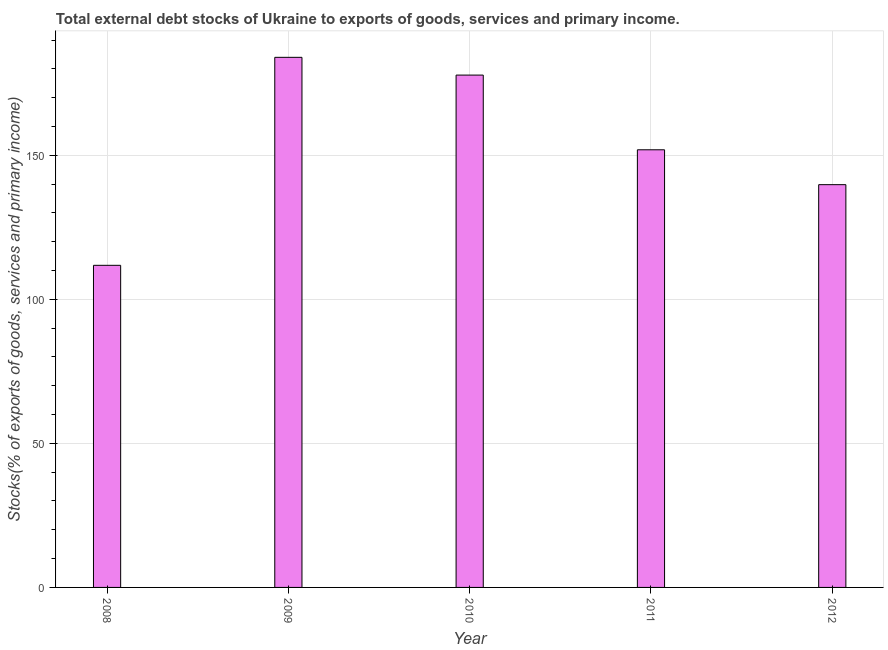Does the graph contain grids?
Offer a terse response. Yes. What is the title of the graph?
Your answer should be compact. Total external debt stocks of Ukraine to exports of goods, services and primary income. What is the label or title of the Y-axis?
Provide a succinct answer. Stocks(% of exports of goods, services and primary income). What is the external debt stocks in 2011?
Give a very brief answer. 151.9. Across all years, what is the maximum external debt stocks?
Give a very brief answer. 183.99. Across all years, what is the minimum external debt stocks?
Provide a short and direct response. 111.79. What is the sum of the external debt stocks?
Make the answer very short. 765.29. What is the difference between the external debt stocks in 2009 and 2012?
Ensure brevity in your answer.  44.19. What is the average external debt stocks per year?
Your answer should be compact. 153.06. What is the median external debt stocks?
Offer a terse response. 151.9. What is the ratio of the external debt stocks in 2008 to that in 2011?
Give a very brief answer. 0.74. Is the external debt stocks in 2010 less than that in 2012?
Provide a short and direct response. No. Is the difference between the external debt stocks in 2010 and 2012 greater than the difference between any two years?
Your response must be concise. No. What is the difference between the highest and the second highest external debt stocks?
Make the answer very short. 6.16. Is the sum of the external debt stocks in 2009 and 2011 greater than the maximum external debt stocks across all years?
Ensure brevity in your answer.  Yes. What is the difference between the highest and the lowest external debt stocks?
Offer a terse response. 72.19. Are all the bars in the graph horizontal?
Provide a succinct answer. No. How many years are there in the graph?
Your answer should be compact. 5. What is the Stocks(% of exports of goods, services and primary income) in 2008?
Offer a terse response. 111.79. What is the Stocks(% of exports of goods, services and primary income) in 2009?
Provide a succinct answer. 183.99. What is the Stocks(% of exports of goods, services and primary income) in 2010?
Your response must be concise. 177.82. What is the Stocks(% of exports of goods, services and primary income) in 2011?
Your response must be concise. 151.9. What is the Stocks(% of exports of goods, services and primary income) of 2012?
Keep it short and to the point. 139.79. What is the difference between the Stocks(% of exports of goods, services and primary income) in 2008 and 2009?
Make the answer very short. -72.19. What is the difference between the Stocks(% of exports of goods, services and primary income) in 2008 and 2010?
Offer a terse response. -66.03. What is the difference between the Stocks(% of exports of goods, services and primary income) in 2008 and 2011?
Provide a short and direct response. -40.1. What is the difference between the Stocks(% of exports of goods, services and primary income) in 2008 and 2012?
Your answer should be compact. -28. What is the difference between the Stocks(% of exports of goods, services and primary income) in 2009 and 2010?
Your answer should be compact. 6.16. What is the difference between the Stocks(% of exports of goods, services and primary income) in 2009 and 2011?
Your answer should be compact. 32.09. What is the difference between the Stocks(% of exports of goods, services and primary income) in 2009 and 2012?
Your response must be concise. 44.19. What is the difference between the Stocks(% of exports of goods, services and primary income) in 2010 and 2011?
Offer a terse response. 25.93. What is the difference between the Stocks(% of exports of goods, services and primary income) in 2010 and 2012?
Make the answer very short. 38.03. What is the difference between the Stocks(% of exports of goods, services and primary income) in 2011 and 2012?
Offer a very short reply. 12.11. What is the ratio of the Stocks(% of exports of goods, services and primary income) in 2008 to that in 2009?
Ensure brevity in your answer.  0.61. What is the ratio of the Stocks(% of exports of goods, services and primary income) in 2008 to that in 2010?
Give a very brief answer. 0.63. What is the ratio of the Stocks(% of exports of goods, services and primary income) in 2008 to that in 2011?
Your response must be concise. 0.74. What is the ratio of the Stocks(% of exports of goods, services and primary income) in 2008 to that in 2012?
Provide a short and direct response. 0.8. What is the ratio of the Stocks(% of exports of goods, services and primary income) in 2009 to that in 2010?
Offer a very short reply. 1.03. What is the ratio of the Stocks(% of exports of goods, services and primary income) in 2009 to that in 2011?
Provide a succinct answer. 1.21. What is the ratio of the Stocks(% of exports of goods, services and primary income) in 2009 to that in 2012?
Keep it short and to the point. 1.32. What is the ratio of the Stocks(% of exports of goods, services and primary income) in 2010 to that in 2011?
Ensure brevity in your answer.  1.17. What is the ratio of the Stocks(% of exports of goods, services and primary income) in 2010 to that in 2012?
Give a very brief answer. 1.27. What is the ratio of the Stocks(% of exports of goods, services and primary income) in 2011 to that in 2012?
Give a very brief answer. 1.09. 